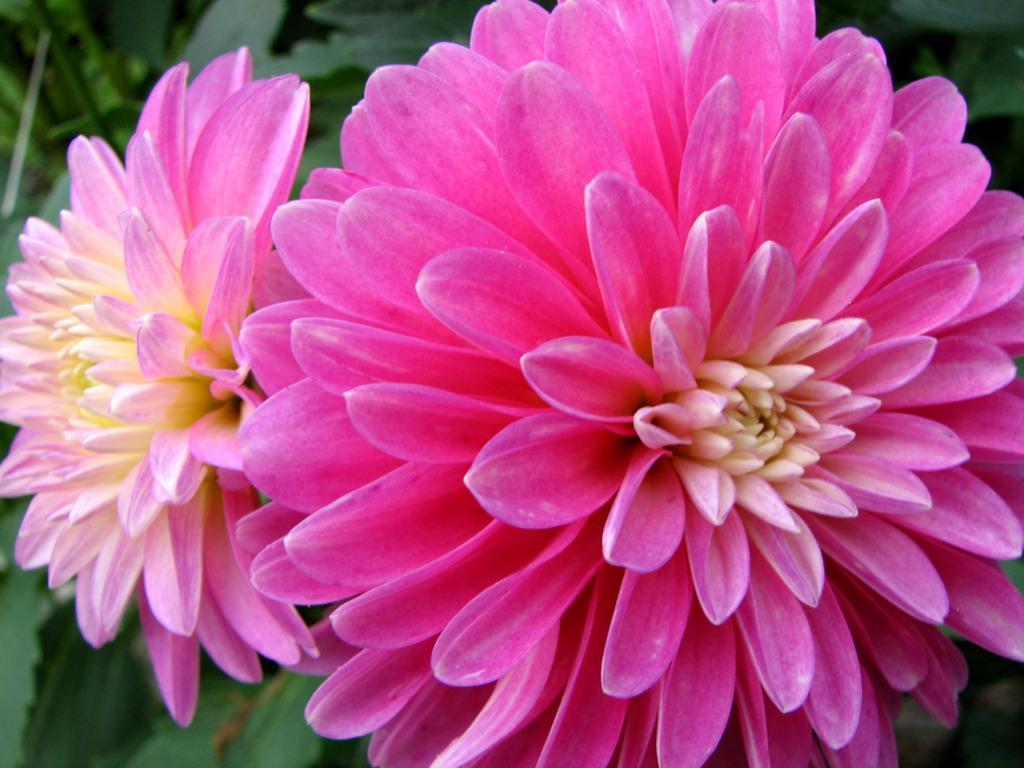Describe this image in one or two sentences. In this image we can see two flowers which are in pink and yellow color and in the background of the image there are some leaves which are green in color. 